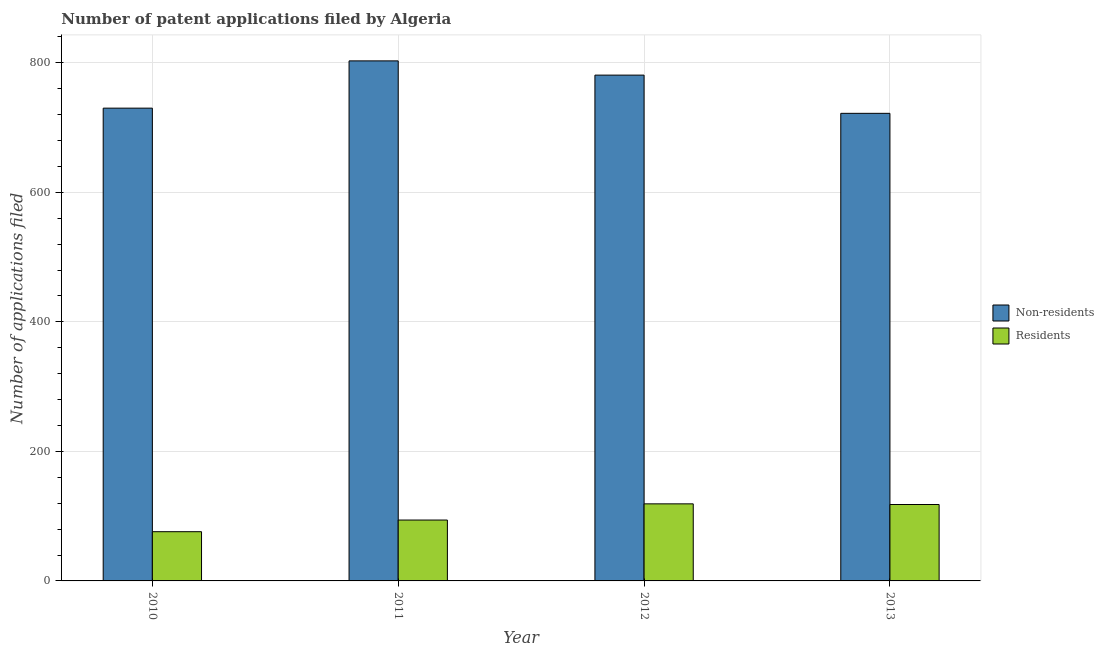How many different coloured bars are there?
Give a very brief answer. 2. How many bars are there on the 3rd tick from the left?
Give a very brief answer. 2. How many bars are there on the 2nd tick from the right?
Your answer should be compact. 2. In how many cases, is the number of bars for a given year not equal to the number of legend labels?
Your answer should be compact. 0. What is the number of patent applications by non residents in 2013?
Provide a succinct answer. 722. Across all years, what is the maximum number of patent applications by non residents?
Your answer should be very brief. 803. Across all years, what is the minimum number of patent applications by non residents?
Provide a succinct answer. 722. In which year was the number of patent applications by non residents maximum?
Keep it short and to the point. 2011. In which year was the number of patent applications by non residents minimum?
Give a very brief answer. 2013. What is the total number of patent applications by residents in the graph?
Keep it short and to the point. 407. What is the difference between the number of patent applications by non residents in 2010 and that in 2011?
Make the answer very short. -73. What is the difference between the number of patent applications by non residents in 2013 and the number of patent applications by residents in 2010?
Offer a very short reply. -8. What is the average number of patent applications by non residents per year?
Keep it short and to the point. 759. In how many years, is the number of patent applications by residents greater than 80?
Offer a very short reply. 3. What is the ratio of the number of patent applications by non residents in 2011 to that in 2012?
Provide a short and direct response. 1.03. Is the difference between the number of patent applications by non residents in 2012 and 2013 greater than the difference between the number of patent applications by residents in 2012 and 2013?
Offer a terse response. No. What is the difference between the highest and the lowest number of patent applications by residents?
Make the answer very short. 43. What does the 1st bar from the left in 2012 represents?
Offer a very short reply. Non-residents. What does the 1st bar from the right in 2013 represents?
Keep it short and to the point. Residents. How many bars are there?
Give a very brief answer. 8. Are all the bars in the graph horizontal?
Keep it short and to the point. No. How many years are there in the graph?
Your answer should be very brief. 4. What is the difference between two consecutive major ticks on the Y-axis?
Make the answer very short. 200. Does the graph contain grids?
Your answer should be very brief. Yes. Where does the legend appear in the graph?
Make the answer very short. Center right. What is the title of the graph?
Give a very brief answer. Number of patent applications filed by Algeria. What is the label or title of the Y-axis?
Your answer should be very brief. Number of applications filed. What is the Number of applications filed of Non-residents in 2010?
Make the answer very short. 730. What is the Number of applications filed of Residents in 2010?
Give a very brief answer. 76. What is the Number of applications filed in Non-residents in 2011?
Ensure brevity in your answer.  803. What is the Number of applications filed in Residents in 2011?
Give a very brief answer. 94. What is the Number of applications filed in Non-residents in 2012?
Your answer should be compact. 781. What is the Number of applications filed of Residents in 2012?
Your answer should be compact. 119. What is the Number of applications filed of Non-residents in 2013?
Your response must be concise. 722. What is the Number of applications filed in Residents in 2013?
Offer a very short reply. 118. Across all years, what is the maximum Number of applications filed in Non-residents?
Keep it short and to the point. 803. Across all years, what is the maximum Number of applications filed in Residents?
Ensure brevity in your answer.  119. Across all years, what is the minimum Number of applications filed in Non-residents?
Offer a very short reply. 722. Across all years, what is the minimum Number of applications filed in Residents?
Ensure brevity in your answer.  76. What is the total Number of applications filed of Non-residents in the graph?
Your response must be concise. 3036. What is the total Number of applications filed of Residents in the graph?
Ensure brevity in your answer.  407. What is the difference between the Number of applications filed in Non-residents in 2010 and that in 2011?
Your response must be concise. -73. What is the difference between the Number of applications filed in Non-residents in 2010 and that in 2012?
Offer a very short reply. -51. What is the difference between the Number of applications filed in Residents in 2010 and that in 2012?
Provide a short and direct response. -43. What is the difference between the Number of applications filed in Non-residents in 2010 and that in 2013?
Your response must be concise. 8. What is the difference between the Number of applications filed of Residents in 2010 and that in 2013?
Your answer should be compact. -42. What is the difference between the Number of applications filed in Non-residents in 2011 and that in 2012?
Keep it short and to the point. 22. What is the difference between the Number of applications filed in Residents in 2012 and that in 2013?
Provide a short and direct response. 1. What is the difference between the Number of applications filed in Non-residents in 2010 and the Number of applications filed in Residents in 2011?
Offer a terse response. 636. What is the difference between the Number of applications filed in Non-residents in 2010 and the Number of applications filed in Residents in 2012?
Offer a terse response. 611. What is the difference between the Number of applications filed in Non-residents in 2010 and the Number of applications filed in Residents in 2013?
Provide a succinct answer. 612. What is the difference between the Number of applications filed of Non-residents in 2011 and the Number of applications filed of Residents in 2012?
Ensure brevity in your answer.  684. What is the difference between the Number of applications filed in Non-residents in 2011 and the Number of applications filed in Residents in 2013?
Your answer should be very brief. 685. What is the difference between the Number of applications filed of Non-residents in 2012 and the Number of applications filed of Residents in 2013?
Your answer should be very brief. 663. What is the average Number of applications filed of Non-residents per year?
Ensure brevity in your answer.  759. What is the average Number of applications filed of Residents per year?
Your answer should be compact. 101.75. In the year 2010, what is the difference between the Number of applications filed of Non-residents and Number of applications filed of Residents?
Offer a very short reply. 654. In the year 2011, what is the difference between the Number of applications filed in Non-residents and Number of applications filed in Residents?
Keep it short and to the point. 709. In the year 2012, what is the difference between the Number of applications filed in Non-residents and Number of applications filed in Residents?
Keep it short and to the point. 662. In the year 2013, what is the difference between the Number of applications filed of Non-residents and Number of applications filed of Residents?
Offer a very short reply. 604. What is the ratio of the Number of applications filed in Residents in 2010 to that in 2011?
Provide a succinct answer. 0.81. What is the ratio of the Number of applications filed in Non-residents in 2010 to that in 2012?
Give a very brief answer. 0.93. What is the ratio of the Number of applications filed in Residents in 2010 to that in 2012?
Your response must be concise. 0.64. What is the ratio of the Number of applications filed in Non-residents in 2010 to that in 2013?
Ensure brevity in your answer.  1.01. What is the ratio of the Number of applications filed of Residents in 2010 to that in 2013?
Offer a very short reply. 0.64. What is the ratio of the Number of applications filed in Non-residents in 2011 to that in 2012?
Keep it short and to the point. 1.03. What is the ratio of the Number of applications filed of Residents in 2011 to that in 2012?
Ensure brevity in your answer.  0.79. What is the ratio of the Number of applications filed in Non-residents in 2011 to that in 2013?
Provide a succinct answer. 1.11. What is the ratio of the Number of applications filed of Residents in 2011 to that in 2013?
Provide a short and direct response. 0.8. What is the ratio of the Number of applications filed of Non-residents in 2012 to that in 2013?
Your answer should be compact. 1.08. What is the ratio of the Number of applications filed in Residents in 2012 to that in 2013?
Ensure brevity in your answer.  1.01. 